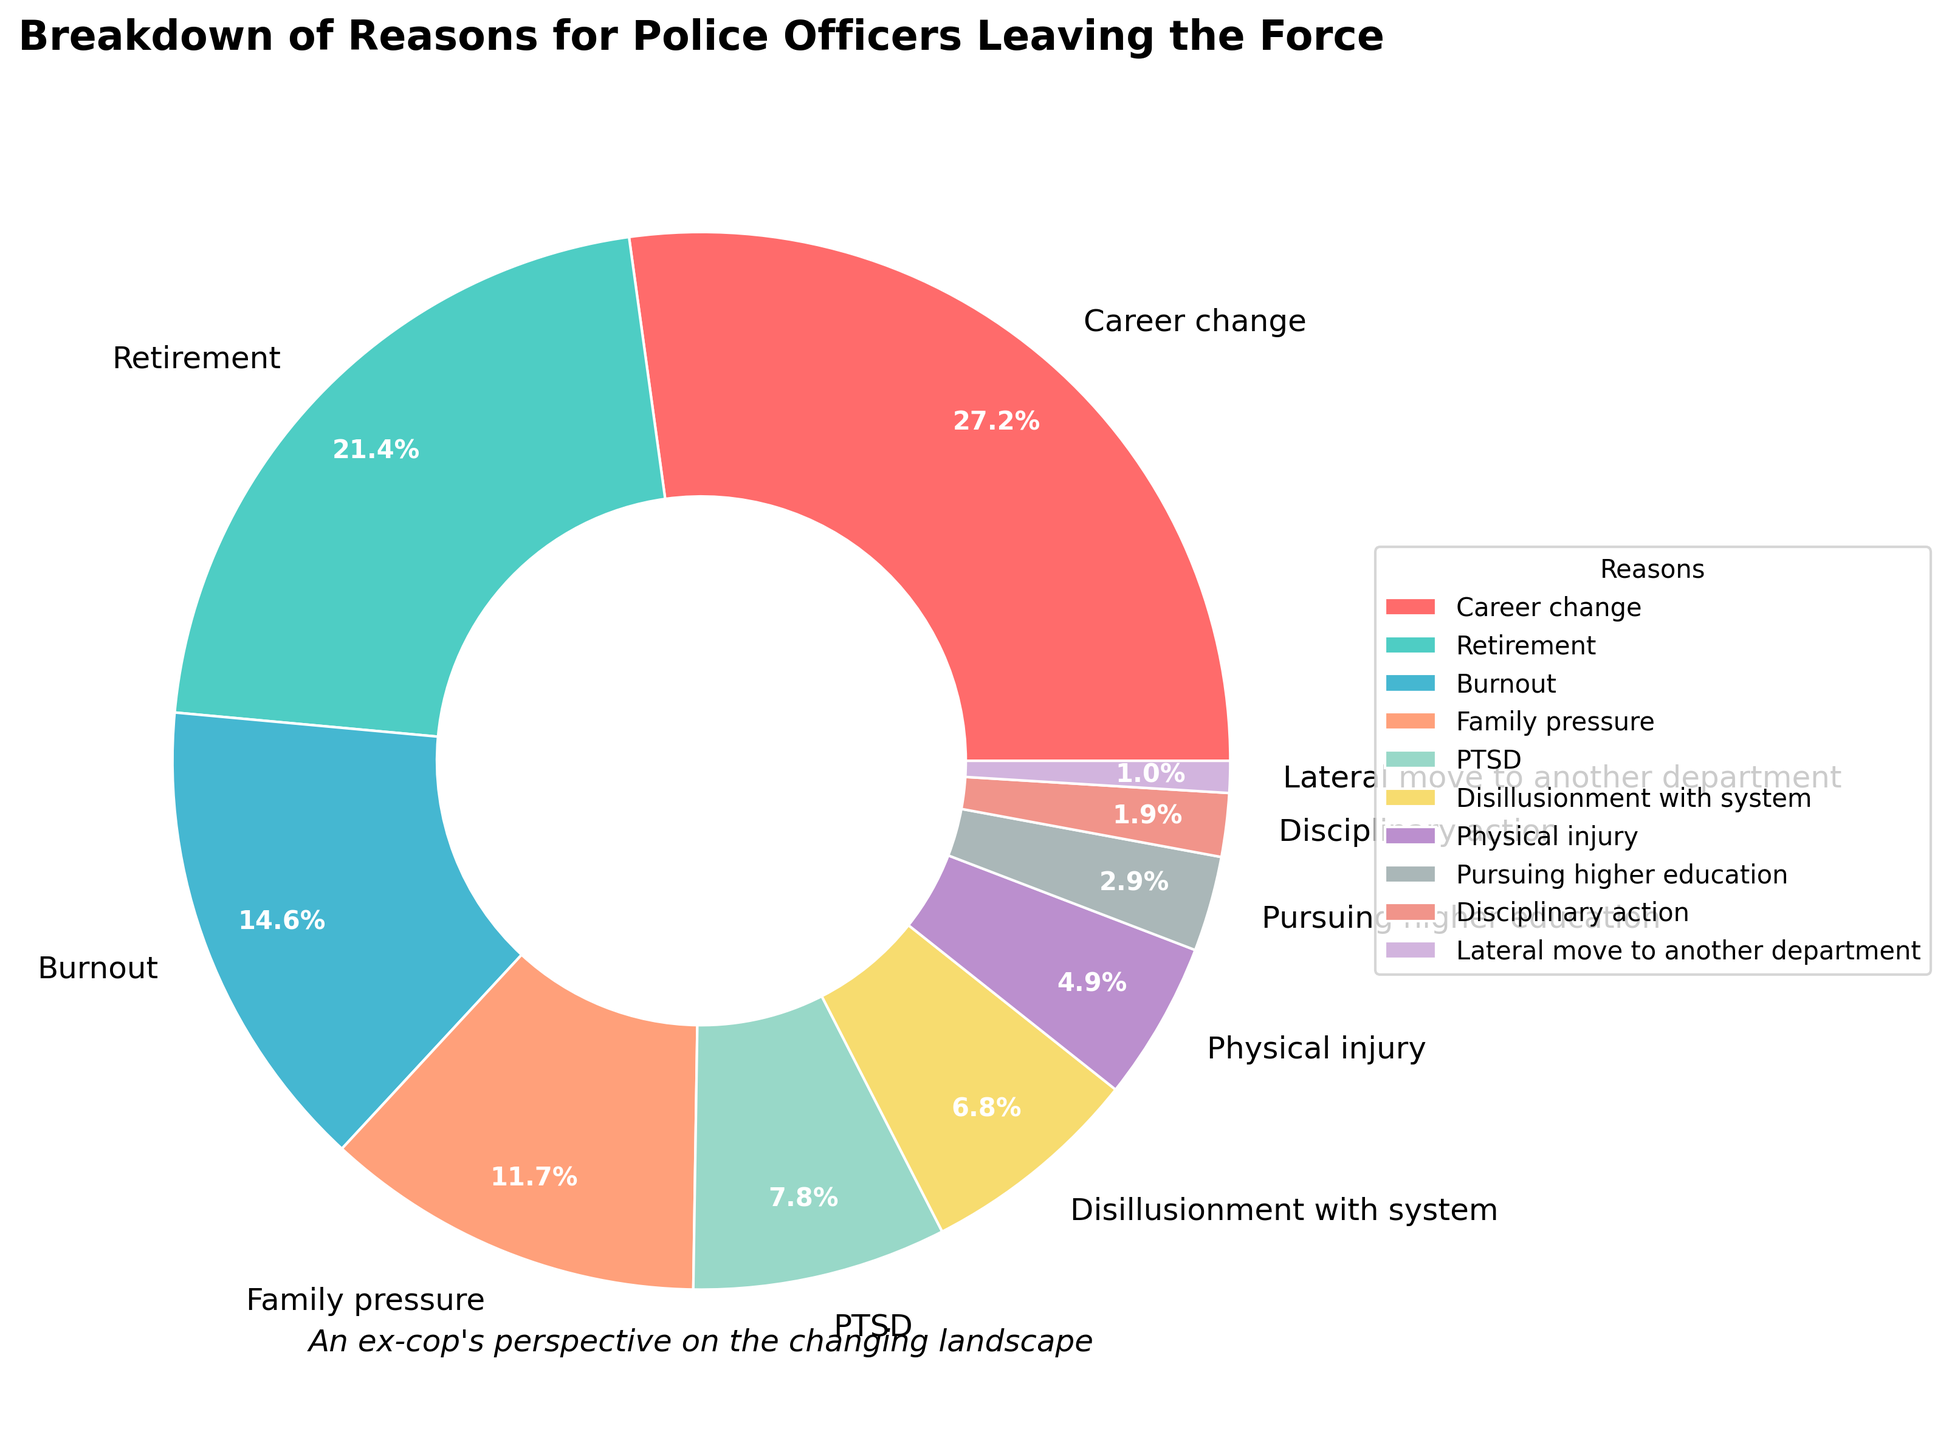What's the largest reason for police officers leaving the force? The figure shows the breakdown of reasons with each segment of the pie chart indicating the percentage. The largest segment corresponds to 'Career change' with 28%.
Answer: Career change Compare the percentage of officers leaving for retirement to those leaving due to burnout. Which is higher, and by how much? Retirement and burnout are adjacent categories. Retirement accounts for 22%, and burnout accounts for 15%. The difference between them is 22% - 15% = 7%.
Answer: Retirement by 7% What is the combined percentage of officers leaving due to family pressure and PTSD? Sum the percentages for family pressure (12%) and PTSD (8%). The combined percentage is 12% + 8% = 20%.
Answer: 20% How does the percentage of officers leaving for a career change compare with those disillusioned with the system? The figure shows 28% for career change and 7% for disillusionment with the system. Career change is a larger segment.
Answer: Career change is greater What is the least common reason for officers leaving the force? The smallest segment represents the category 'Lateral move to another department', which accounts for 1%.
Answer: Lateral move to another department Which reason accounts for more, physical injury or pursuing higher education? Examine the chart segment for physical injury (5%) and pursuing higher education (3%). Physical injury is larger.
Answer: Physical injury What is the total percentage of officers leaving due to career change, retirement, and burnout combined? Add the percentages for career change (28%), retirement (22%), and burnout (15%). The total is 28% + 22% + 15% = 65%.
Answer: 65% Which segments of the pie chart are represented in different shades of blue or green, and what are their corresponding reasons? The chart uses custom colors and visual inspection shows shades of blue or green for the categories 'Retirement' (greenish, 22%), 'PTSD' (blue, 8%), and 'Disillusionment with system' (greenish-yellow, 7%).
Answer: Retirement, PTSD, Disillusionment with system Is the percentage of officers leaving due to burnout closer to that of family pressure or PTSD? Compare the percentage for burnout (15%) to family pressure (12%) and PTSD (8%). 15% is closer to 12% (3% difference) than to 8% (7% difference).
Answer: Family pressure How much more common is family pressure as a reason for leaving compared to the combination of disciplinary action and lateral move to another department? Family pressure accounts for 12%. Combine disciplinary action (2%) and lateral move (1%) for a total of 3%. The difference is 12% - 3% = 9%.
Answer: 9% 